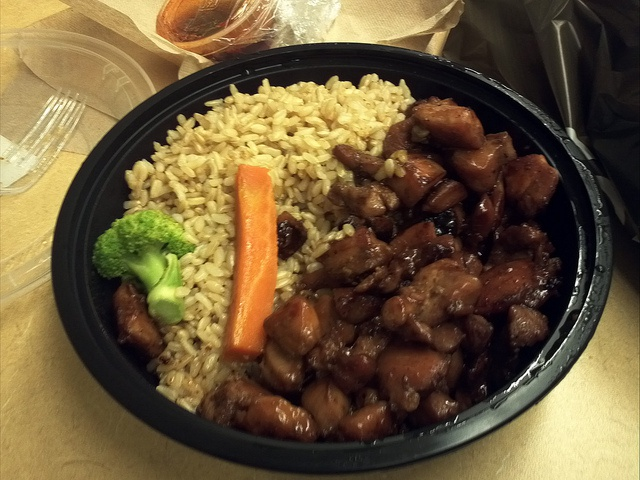Describe the objects in this image and their specific colors. I can see dining table in black, tan, maroon, olive, and khaki tones, bowl in tan, black, maroon, and olive tones, carrot in tan, orange, red, and brown tones, broccoli in tan, darkgreen, and olive tones, and fork in tan and khaki tones in this image. 